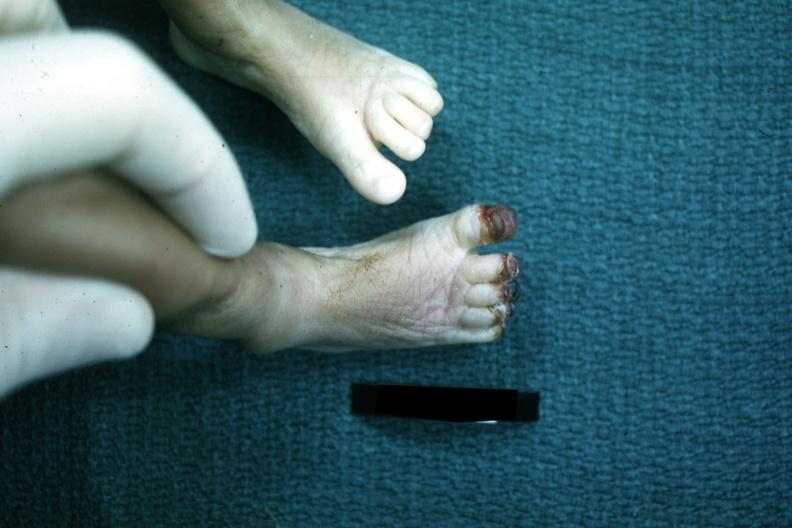what does this image show?
Answer the question using a single word or phrase. Foot of infant with gangrenous tips of all toes case of sepsis with dic 